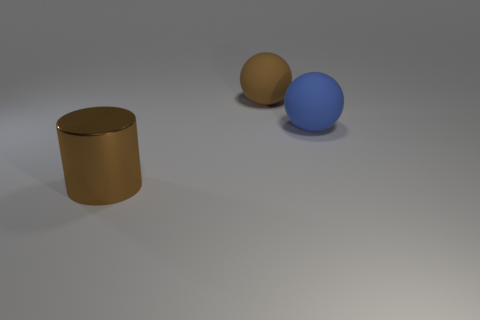Is the blue matte object the same shape as the large brown matte object?
Make the answer very short. Yes. What number of other objects are the same shape as the brown matte thing?
Ensure brevity in your answer.  1. There is another matte object that is the same size as the brown matte object; what is its color?
Give a very brief answer. Blue. Is the number of rubber things that are behind the brown cylinder the same as the number of metallic cylinders?
Provide a succinct answer. No. There is a big object that is on the left side of the big blue matte ball and in front of the brown ball; what shape is it?
Make the answer very short. Cylinder. Is there a big cylinder that has the same material as the blue ball?
Your answer should be compact. No. There is a matte thing that is the same color as the big metal cylinder; what size is it?
Provide a short and direct response. Large. What number of large things are both on the left side of the large blue rubber object and behind the large brown shiny thing?
Provide a short and direct response. 1. There is a large thing on the left side of the brown ball; what is it made of?
Your response must be concise. Metal. How many large rubber spheres have the same color as the cylinder?
Provide a short and direct response. 1. 